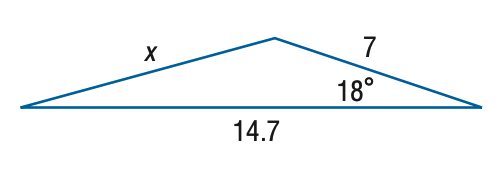Answer the mathemtical geometry problem and directly provide the correct option letter.
Question: Find x. Round the side measure to the nearest tenth.
Choices: A: 4.2 B: 8.3 C: 16.7 D: 69.4 B 